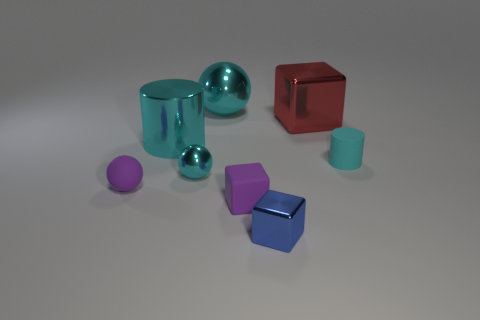Are any small brown shiny cubes visible?
Ensure brevity in your answer.  No. There is a purple object that is the same shape as the big red metallic thing; what material is it?
Give a very brief answer. Rubber. What shape is the matte thing right of the metal thing that is in front of the object that is to the left of the big shiny cylinder?
Your response must be concise. Cylinder. There is another cylinder that is the same color as the large shiny cylinder; what is it made of?
Your answer should be compact. Rubber. How many blue matte objects have the same shape as the tiny cyan metallic object?
Offer a very short reply. 0. Do the object behind the large red metal object and the small metallic thing behind the blue metal object have the same color?
Your response must be concise. Yes. What material is the purple ball that is the same size as the rubber cylinder?
Offer a very short reply. Rubber. Is there a cyan block of the same size as the purple block?
Provide a short and direct response. No. Is the number of large cyan objects in front of the small cyan rubber cylinder less than the number of big red blocks?
Give a very brief answer. Yes. Are there fewer small cyan things that are on the right side of the big sphere than tiny shiny objects on the right side of the purple block?
Ensure brevity in your answer.  No. 